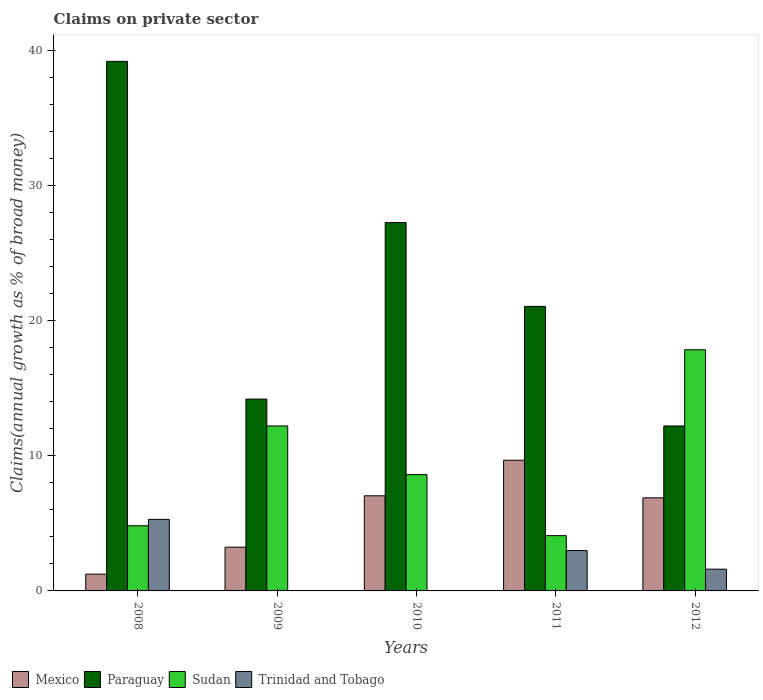How many groups of bars are there?
Your response must be concise. 5. Are the number of bars per tick equal to the number of legend labels?
Offer a very short reply. No. In how many cases, is the number of bars for a given year not equal to the number of legend labels?
Make the answer very short. 2. What is the percentage of broad money claimed on private sector in Sudan in 2010?
Offer a terse response. 8.61. Across all years, what is the maximum percentage of broad money claimed on private sector in Paraguay?
Your answer should be very brief. 39.21. Across all years, what is the minimum percentage of broad money claimed on private sector in Sudan?
Provide a short and direct response. 4.09. In which year was the percentage of broad money claimed on private sector in Sudan maximum?
Make the answer very short. 2012. What is the total percentage of broad money claimed on private sector in Paraguay in the graph?
Make the answer very short. 113.96. What is the difference between the percentage of broad money claimed on private sector in Sudan in 2011 and that in 2012?
Your answer should be compact. -13.76. What is the difference between the percentage of broad money claimed on private sector in Trinidad and Tobago in 2010 and the percentage of broad money claimed on private sector in Mexico in 2009?
Your answer should be compact. -3.24. What is the average percentage of broad money claimed on private sector in Sudan per year?
Provide a short and direct response. 9.52. In the year 2012, what is the difference between the percentage of broad money claimed on private sector in Mexico and percentage of broad money claimed on private sector in Paraguay?
Ensure brevity in your answer.  -5.32. What is the ratio of the percentage of broad money claimed on private sector in Sudan in 2009 to that in 2010?
Keep it short and to the point. 1.42. Is the percentage of broad money claimed on private sector in Paraguay in 2008 less than that in 2012?
Your response must be concise. No. What is the difference between the highest and the second highest percentage of broad money claimed on private sector in Trinidad and Tobago?
Make the answer very short. 2.31. What is the difference between the highest and the lowest percentage of broad money claimed on private sector in Trinidad and Tobago?
Provide a short and direct response. 5.3. Is it the case that in every year, the sum of the percentage of broad money claimed on private sector in Mexico and percentage of broad money claimed on private sector in Paraguay is greater than the sum of percentage of broad money claimed on private sector in Trinidad and Tobago and percentage of broad money claimed on private sector in Sudan?
Your response must be concise. No. Is it the case that in every year, the sum of the percentage of broad money claimed on private sector in Paraguay and percentage of broad money claimed on private sector in Trinidad and Tobago is greater than the percentage of broad money claimed on private sector in Sudan?
Make the answer very short. No. How many years are there in the graph?
Your answer should be very brief. 5. Are the values on the major ticks of Y-axis written in scientific E-notation?
Provide a succinct answer. No. Does the graph contain grids?
Give a very brief answer. No. Where does the legend appear in the graph?
Offer a very short reply. Bottom left. What is the title of the graph?
Keep it short and to the point. Claims on private sector. What is the label or title of the Y-axis?
Ensure brevity in your answer.  Claims(annual growth as % of broad money). What is the Claims(annual growth as % of broad money) of Mexico in 2008?
Your answer should be very brief. 1.24. What is the Claims(annual growth as % of broad money) of Paraguay in 2008?
Offer a very short reply. 39.21. What is the Claims(annual growth as % of broad money) of Sudan in 2008?
Ensure brevity in your answer.  4.82. What is the Claims(annual growth as % of broad money) in Trinidad and Tobago in 2008?
Ensure brevity in your answer.  5.3. What is the Claims(annual growth as % of broad money) in Mexico in 2009?
Offer a very short reply. 3.24. What is the Claims(annual growth as % of broad money) of Paraguay in 2009?
Keep it short and to the point. 14.2. What is the Claims(annual growth as % of broad money) of Sudan in 2009?
Make the answer very short. 12.21. What is the Claims(annual growth as % of broad money) in Trinidad and Tobago in 2009?
Keep it short and to the point. 0. What is the Claims(annual growth as % of broad money) of Mexico in 2010?
Provide a succinct answer. 7.04. What is the Claims(annual growth as % of broad money) in Paraguay in 2010?
Offer a very short reply. 27.27. What is the Claims(annual growth as % of broad money) of Sudan in 2010?
Make the answer very short. 8.61. What is the Claims(annual growth as % of broad money) in Trinidad and Tobago in 2010?
Offer a very short reply. 0. What is the Claims(annual growth as % of broad money) of Mexico in 2011?
Your answer should be very brief. 9.68. What is the Claims(annual growth as % of broad money) in Paraguay in 2011?
Offer a very short reply. 21.06. What is the Claims(annual growth as % of broad money) in Sudan in 2011?
Your answer should be very brief. 4.09. What is the Claims(annual growth as % of broad money) of Trinidad and Tobago in 2011?
Your answer should be very brief. 2.99. What is the Claims(annual growth as % of broad money) in Mexico in 2012?
Make the answer very short. 6.89. What is the Claims(annual growth as % of broad money) in Paraguay in 2012?
Your response must be concise. 12.21. What is the Claims(annual growth as % of broad money) of Sudan in 2012?
Offer a terse response. 17.85. What is the Claims(annual growth as % of broad money) in Trinidad and Tobago in 2012?
Provide a succinct answer. 1.61. Across all years, what is the maximum Claims(annual growth as % of broad money) in Mexico?
Give a very brief answer. 9.68. Across all years, what is the maximum Claims(annual growth as % of broad money) of Paraguay?
Your response must be concise. 39.21. Across all years, what is the maximum Claims(annual growth as % of broad money) of Sudan?
Give a very brief answer. 17.85. Across all years, what is the maximum Claims(annual growth as % of broad money) of Trinidad and Tobago?
Your answer should be very brief. 5.3. Across all years, what is the minimum Claims(annual growth as % of broad money) in Mexico?
Your answer should be very brief. 1.24. Across all years, what is the minimum Claims(annual growth as % of broad money) in Paraguay?
Offer a very short reply. 12.21. Across all years, what is the minimum Claims(annual growth as % of broad money) of Sudan?
Ensure brevity in your answer.  4.09. Across all years, what is the minimum Claims(annual growth as % of broad money) of Trinidad and Tobago?
Ensure brevity in your answer.  0. What is the total Claims(annual growth as % of broad money) in Mexico in the graph?
Your answer should be compact. 28.1. What is the total Claims(annual growth as % of broad money) in Paraguay in the graph?
Provide a succinct answer. 113.96. What is the total Claims(annual growth as % of broad money) of Sudan in the graph?
Keep it short and to the point. 47.59. What is the total Claims(annual growth as % of broad money) of Trinidad and Tobago in the graph?
Ensure brevity in your answer.  9.9. What is the difference between the Claims(annual growth as % of broad money) in Mexico in 2008 and that in 2009?
Give a very brief answer. -2. What is the difference between the Claims(annual growth as % of broad money) of Paraguay in 2008 and that in 2009?
Your answer should be compact. 25. What is the difference between the Claims(annual growth as % of broad money) in Sudan in 2008 and that in 2009?
Keep it short and to the point. -7.39. What is the difference between the Claims(annual growth as % of broad money) of Mexico in 2008 and that in 2010?
Make the answer very short. -5.8. What is the difference between the Claims(annual growth as % of broad money) of Paraguay in 2008 and that in 2010?
Offer a very short reply. 11.93. What is the difference between the Claims(annual growth as % of broad money) in Sudan in 2008 and that in 2010?
Your answer should be compact. -3.79. What is the difference between the Claims(annual growth as % of broad money) in Mexico in 2008 and that in 2011?
Provide a succinct answer. -8.43. What is the difference between the Claims(annual growth as % of broad money) in Paraguay in 2008 and that in 2011?
Keep it short and to the point. 18.14. What is the difference between the Claims(annual growth as % of broad money) in Sudan in 2008 and that in 2011?
Keep it short and to the point. 0.73. What is the difference between the Claims(annual growth as % of broad money) in Trinidad and Tobago in 2008 and that in 2011?
Your response must be concise. 2.31. What is the difference between the Claims(annual growth as % of broad money) of Mexico in 2008 and that in 2012?
Ensure brevity in your answer.  -5.65. What is the difference between the Claims(annual growth as % of broad money) of Paraguay in 2008 and that in 2012?
Provide a succinct answer. 27. What is the difference between the Claims(annual growth as % of broad money) of Sudan in 2008 and that in 2012?
Your answer should be very brief. -13.03. What is the difference between the Claims(annual growth as % of broad money) of Trinidad and Tobago in 2008 and that in 2012?
Your answer should be very brief. 3.68. What is the difference between the Claims(annual growth as % of broad money) of Mexico in 2009 and that in 2010?
Keep it short and to the point. -3.8. What is the difference between the Claims(annual growth as % of broad money) of Paraguay in 2009 and that in 2010?
Ensure brevity in your answer.  -13.07. What is the difference between the Claims(annual growth as % of broad money) of Sudan in 2009 and that in 2010?
Make the answer very short. 3.6. What is the difference between the Claims(annual growth as % of broad money) in Mexico in 2009 and that in 2011?
Keep it short and to the point. -6.44. What is the difference between the Claims(annual growth as % of broad money) of Paraguay in 2009 and that in 2011?
Make the answer very short. -6.86. What is the difference between the Claims(annual growth as % of broad money) of Sudan in 2009 and that in 2011?
Give a very brief answer. 8.12. What is the difference between the Claims(annual growth as % of broad money) of Mexico in 2009 and that in 2012?
Make the answer very short. -3.65. What is the difference between the Claims(annual growth as % of broad money) of Paraguay in 2009 and that in 2012?
Offer a terse response. 1.99. What is the difference between the Claims(annual growth as % of broad money) of Sudan in 2009 and that in 2012?
Offer a terse response. -5.64. What is the difference between the Claims(annual growth as % of broad money) in Mexico in 2010 and that in 2011?
Provide a short and direct response. -2.63. What is the difference between the Claims(annual growth as % of broad money) of Paraguay in 2010 and that in 2011?
Make the answer very short. 6.21. What is the difference between the Claims(annual growth as % of broad money) of Sudan in 2010 and that in 2011?
Ensure brevity in your answer.  4.52. What is the difference between the Claims(annual growth as % of broad money) in Mexico in 2010 and that in 2012?
Provide a short and direct response. 0.15. What is the difference between the Claims(annual growth as % of broad money) of Paraguay in 2010 and that in 2012?
Provide a short and direct response. 15.06. What is the difference between the Claims(annual growth as % of broad money) in Sudan in 2010 and that in 2012?
Provide a succinct answer. -9.24. What is the difference between the Claims(annual growth as % of broad money) of Mexico in 2011 and that in 2012?
Make the answer very short. 2.78. What is the difference between the Claims(annual growth as % of broad money) of Paraguay in 2011 and that in 2012?
Offer a very short reply. 8.85. What is the difference between the Claims(annual growth as % of broad money) of Sudan in 2011 and that in 2012?
Offer a terse response. -13.76. What is the difference between the Claims(annual growth as % of broad money) in Trinidad and Tobago in 2011 and that in 2012?
Your response must be concise. 1.38. What is the difference between the Claims(annual growth as % of broad money) of Mexico in 2008 and the Claims(annual growth as % of broad money) of Paraguay in 2009?
Make the answer very short. -12.96. What is the difference between the Claims(annual growth as % of broad money) in Mexico in 2008 and the Claims(annual growth as % of broad money) in Sudan in 2009?
Provide a succinct answer. -10.97. What is the difference between the Claims(annual growth as % of broad money) in Paraguay in 2008 and the Claims(annual growth as % of broad money) in Sudan in 2009?
Keep it short and to the point. 27. What is the difference between the Claims(annual growth as % of broad money) of Mexico in 2008 and the Claims(annual growth as % of broad money) of Paraguay in 2010?
Offer a very short reply. -26.03. What is the difference between the Claims(annual growth as % of broad money) in Mexico in 2008 and the Claims(annual growth as % of broad money) in Sudan in 2010?
Give a very brief answer. -7.37. What is the difference between the Claims(annual growth as % of broad money) of Paraguay in 2008 and the Claims(annual growth as % of broad money) of Sudan in 2010?
Your answer should be very brief. 30.6. What is the difference between the Claims(annual growth as % of broad money) in Mexico in 2008 and the Claims(annual growth as % of broad money) in Paraguay in 2011?
Offer a terse response. -19.82. What is the difference between the Claims(annual growth as % of broad money) of Mexico in 2008 and the Claims(annual growth as % of broad money) of Sudan in 2011?
Ensure brevity in your answer.  -2.85. What is the difference between the Claims(annual growth as % of broad money) in Mexico in 2008 and the Claims(annual growth as % of broad money) in Trinidad and Tobago in 2011?
Offer a very short reply. -1.75. What is the difference between the Claims(annual growth as % of broad money) of Paraguay in 2008 and the Claims(annual growth as % of broad money) of Sudan in 2011?
Your answer should be compact. 35.12. What is the difference between the Claims(annual growth as % of broad money) of Paraguay in 2008 and the Claims(annual growth as % of broad money) of Trinidad and Tobago in 2011?
Give a very brief answer. 36.22. What is the difference between the Claims(annual growth as % of broad money) in Sudan in 2008 and the Claims(annual growth as % of broad money) in Trinidad and Tobago in 2011?
Give a very brief answer. 1.83. What is the difference between the Claims(annual growth as % of broad money) in Mexico in 2008 and the Claims(annual growth as % of broad money) in Paraguay in 2012?
Offer a very short reply. -10.97. What is the difference between the Claims(annual growth as % of broad money) of Mexico in 2008 and the Claims(annual growth as % of broad money) of Sudan in 2012?
Keep it short and to the point. -16.61. What is the difference between the Claims(annual growth as % of broad money) in Mexico in 2008 and the Claims(annual growth as % of broad money) in Trinidad and Tobago in 2012?
Ensure brevity in your answer.  -0.37. What is the difference between the Claims(annual growth as % of broad money) in Paraguay in 2008 and the Claims(annual growth as % of broad money) in Sudan in 2012?
Provide a short and direct response. 21.35. What is the difference between the Claims(annual growth as % of broad money) of Paraguay in 2008 and the Claims(annual growth as % of broad money) of Trinidad and Tobago in 2012?
Provide a succinct answer. 37.6. What is the difference between the Claims(annual growth as % of broad money) in Sudan in 2008 and the Claims(annual growth as % of broad money) in Trinidad and Tobago in 2012?
Ensure brevity in your answer.  3.21. What is the difference between the Claims(annual growth as % of broad money) in Mexico in 2009 and the Claims(annual growth as % of broad money) in Paraguay in 2010?
Your answer should be very brief. -24.03. What is the difference between the Claims(annual growth as % of broad money) in Mexico in 2009 and the Claims(annual growth as % of broad money) in Sudan in 2010?
Provide a short and direct response. -5.37. What is the difference between the Claims(annual growth as % of broad money) of Paraguay in 2009 and the Claims(annual growth as % of broad money) of Sudan in 2010?
Your response must be concise. 5.6. What is the difference between the Claims(annual growth as % of broad money) in Mexico in 2009 and the Claims(annual growth as % of broad money) in Paraguay in 2011?
Your answer should be compact. -17.82. What is the difference between the Claims(annual growth as % of broad money) of Mexico in 2009 and the Claims(annual growth as % of broad money) of Sudan in 2011?
Make the answer very short. -0.85. What is the difference between the Claims(annual growth as % of broad money) in Mexico in 2009 and the Claims(annual growth as % of broad money) in Trinidad and Tobago in 2011?
Your answer should be very brief. 0.25. What is the difference between the Claims(annual growth as % of broad money) in Paraguay in 2009 and the Claims(annual growth as % of broad money) in Sudan in 2011?
Provide a succinct answer. 10.11. What is the difference between the Claims(annual growth as % of broad money) of Paraguay in 2009 and the Claims(annual growth as % of broad money) of Trinidad and Tobago in 2011?
Make the answer very short. 11.22. What is the difference between the Claims(annual growth as % of broad money) of Sudan in 2009 and the Claims(annual growth as % of broad money) of Trinidad and Tobago in 2011?
Keep it short and to the point. 9.22. What is the difference between the Claims(annual growth as % of broad money) in Mexico in 2009 and the Claims(annual growth as % of broad money) in Paraguay in 2012?
Your answer should be very brief. -8.97. What is the difference between the Claims(annual growth as % of broad money) of Mexico in 2009 and the Claims(annual growth as % of broad money) of Sudan in 2012?
Provide a succinct answer. -14.62. What is the difference between the Claims(annual growth as % of broad money) in Mexico in 2009 and the Claims(annual growth as % of broad money) in Trinidad and Tobago in 2012?
Offer a very short reply. 1.63. What is the difference between the Claims(annual growth as % of broad money) in Paraguay in 2009 and the Claims(annual growth as % of broad money) in Sudan in 2012?
Your answer should be compact. -3.65. What is the difference between the Claims(annual growth as % of broad money) of Paraguay in 2009 and the Claims(annual growth as % of broad money) of Trinidad and Tobago in 2012?
Give a very brief answer. 12.59. What is the difference between the Claims(annual growth as % of broad money) in Sudan in 2009 and the Claims(annual growth as % of broad money) in Trinidad and Tobago in 2012?
Your answer should be very brief. 10.6. What is the difference between the Claims(annual growth as % of broad money) in Mexico in 2010 and the Claims(annual growth as % of broad money) in Paraguay in 2011?
Offer a very short reply. -14.02. What is the difference between the Claims(annual growth as % of broad money) in Mexico in 2010 and the Claims(annual growth as % of broad money) in Sudan in 2011?
Ensure brevity in your answer.  2.95. What is the difference between the Claims(annual growth as % of broad money) of Mexico in 2010 and the Claims(annual growth as % of broad money) of Trinidad and Tobago in 2011?
Provide a succinct answer. 4.06. What is the difference between the Claims(annual growth as % of broad money) in Paraguay in 2010 and the Claims(annual growth as % of broad money) in Sudan in 2011?
Offer a very short reply. 23.18. What is the difference between the Claims(annual growth as % of broad money) in Paraguay in 2010 and the Claims(annual growth as % of broad money) in Trinidad and Tobago in 2011?
Your answer should be very brief. 24.29. What is the difference between the Claims(annual growth as % of broad money) in Sudan in 2010 and the Claims(annual growth as % of broad money) in Trinidad and Tobago in 2011?
Offer a terse response. 5.62. What is the difference between the Claims(annual growth as % of broad money) of Mexico in 2010 and the Claims(annual growth as % of broad money) of Paraguay in 2012?
Your response must be concise. -5.17. What is the difference between the Claims(annual growth as % of broad money) of Mexico in 2010 and the Claims(annual growth as % of broad money) of Sudan in 2012?
Keep it short and to the point. -10.81. What is the difference between the Claims(annual growth as % of broad money) in Mexico in 2010 and the Claims(annual growth as % of broad money) in Trinidad and Tobago in 2012?
Provide a short and direct response. 5.43. What is the difference between the Claims(annual growth as % of broad money) in Paraguay in 2010 and the Claims(annual growth as % of broad money) in Sudan in 2012?
Provide a succinct answer. 9.42. What is the difference between the Claims(annual growth as % of broad money) of Paraguay in 2010 and the Claims(annual growth as % of broad money) of Trinidad and Tobago in 2012?
Your answer should be compact. 25.66. What is the difference between the Claims(annual growth as % of broad money) of Sudan in 2010 and the Claims(annual growth as % of broad money) of Trinidad and Tobago in 2012?
Offer a very short reply. 7. What is the difference between the Claims(annual growth as % of broad money) of Mexico in 2011 and the Claims(annual growth as % of broad money) of Paraguay in 2012?
Your answer should be very brief. -2.54. What is the difference between the Claims(annual growth as % of broad money) in Mexico in 2011 and the Claims(annual growth as % of broad money) in Sudan in 2012?
Offer a very short reply. -8.18. What is the difference between the Claims(annual growth as % of broad money) of Mexico in 2011 and the Claims(annual growth as % of broad money) of Trinidad and Tobago in 2012?
Provide a succinct answer. 8.07. What is the difference between the Claims(annual growth as % of broad money) of Paraguay in 2011 and the Claims(annual growth as % of broad money) of Sudan in 2012?
Give a very brief answer. 3.21. What is the difference between the Claims(annual growth as % of broad money) of Paraguay in 2011 and the Claims(annual growth as % of broad money) of Trinidad and Tobago in 2012?
Give a very brief answer. 19.45. What is the difference between the Claims(annual growth as % of broad money) in Sudan in 2011 and the Claims(annual growth as % of broad money) in Trinidad and Tobago in 2012?
Provide a short and direct response. 2.48. What is the average Claims(annual growth as % of broad money) of Mexico per year?
Your answer should be compact. 5.62. What is the average Claims(annual growth as % of broad money) of Paraguay per year?
Provide a short and direct response. 22.79. What is the average Claims(annual growth as % of broad money) of Sudan per year?
Your answer should be very brief. 9.52. What is the average Claims(annual growth as % of broad money) in Trinidad and Tobago per year?
Keep it short and to the point. 1.98. In the year 2008, what is the difference between the Claims(annual growth as % of broad money) of Mexico and Claims(annual growth as % of broad money) of Paraguay?
Give a very brief answer. -37.97. In the year 2008, what is the difference between the Claims(annual growth as % of broad money) of Mexico and Claims(annual growth as % of broad money) of Sudan?
Make the answer very short. -3.58. In the year 2008, what is the difference between the Claims(annual growth as % of broad money) of Mexico and Claims(annual growth as % of broad money) of Trinidad and Tobago?
Keep it short and to the point. -4.05. In the year 2008, what is the difference between the Claims(annual growth as % of broad money) in Paraguay and Claims(annual growth as % of broad money) in Sudan?
Provide a succinct answer. 34.39. In the year 2008, what is the difference between the Claims(annual growth as % of broad money) in Paraguay and Claims(annual growth as % of broad money) in Trinidad and Tobago?
Offer a terse response. 33.91. In the year 2008, what is the difference between the Claims(annual growth as % of broad money) in Sudan and Claims(annual growth as % of broad money) in Trinidad and Tobago?
Ensure brevity in your answer.  -0.47. In the year 2009, what is the difference between the Claims(annual growth as % of broad money) in Mexico and Claims(annual growth as % of broad money) in Paraguay?
Give a very brief answer. -10.97. In the year 2009, what is the difference between the Claims(annual growth as % of broad money) of Mexico and Claims(annual growth as % of broad money) of Sudan?
Ensure brevity in your answer.  -8.97. In the year 2009, what is the difference between the Claims(annual growth as % of broad money) in Paraguay and Claims(annual growth as % of broad money) in Sudan?
Give a very brief answer. 1.99. In the year 2010, what is the difference between the Claims(annual growth as % of broad money) in Mexico and Claims(annual growth as % of broad money) in Paraguay?
Offer a very short reply. -20.23. In the year 2010, what is the difference between the Claims(annual growth as % of broad money) of Mexico and Claims(annual growth as % of broad money) of Sudan?
Provide a short and direct response. -1.57. In the year 2010, what is the difference between the Claims(annual growth as % of broad money) of Paraguay and Claims(annual growth as % of broad money) of Sudan?
Keep it short and to the point. 18.66. In the year 2011, what is the difference between the Claims(annual growth as % of broad money) in Mexico and Claims(annual growth as % of broad money) in Paraguay?
Provide a short and direct response. -11.39. In the year 2011, what is the difference between the Claims(annual growth as % of broad money) in Mexico and Claims(annual growth as % of broad money) in Sudan?
Provide a short and direct response. 5.58. In the year 2011, what is the difference between the Claims(annual growth as % of broad money) of Mexico and Claims(annual growth as % of broad money) of Trinidad and Tobago?
Give a very brief answer. 6.69. In the year 2011, what is the difference between the Claims(annual growth as % of broad money) in Paraguay and Claims(annual growth as % of broad money) in Sudan?
Your answer should be compact. 16.97. In the year 2011, what is the difference between the Claims(annual growth as % of broad money) of Paraguay and Claims(annual growth as % of broad money) of Trinidad and Tobago?
Your answer should be very brief. 18.08. In the year 2011, what is the difference between the Claims(annual growth as % of broad money) in Sudan and Claims(annual growth as % of broad money) in Trinidad and Tobago?
Your answer should be very brief. 1.1. In the year 2012, what is the difference between the Claims(annual growth as % of broad money) of Mexico and Claims(annual growth as % of broad money) of Paraguay?
Offer a very short reply. -5.32. In the year 2012, what is the difference between the Claims(annual growth as % of broad money) in Mexico and Claims(annual growth as % of broad money) in Sudan?
Keep it short and to the point. -10.96. In the year 2012, what is the difference between the Claims(annual growth as % of broad money) in Mexico and Claims(annual growth as % of broad money) in Trinidad and Tobago?
Provide a short and direct response. 5.28. In the year 2012, what is the difference between the Claims(annual growth as % of broad money) of Paraguay and Claims(annual growth as % of broad money) of Sudan?
Your answer should be compact. -5.64. In the year 2012, what is the difference between the Claims(annual growth as % of broad money) of Paraguay and Claims(annual growth as % of broad money) of Trinidad and Tobago?
Ensure brevity in your answer.  10.6. In the year 2012, what is the difference between the Claims(annual growth as % of broad money) of Sudan and Claims(annual growth as % of broad money) of Trinidad and Tobago?
Ensure brevity in your answer.  16.24. What is the ratio of the Claims(annual growth as % of broad money) of Mexico in 2008 to that in 2009?
Make the answer very short. 0.38. What is the ratio of the Claims(annual growth as % of broad money) of Paraguay in 2008 to that in 2009?
Your response must be concise. 2.76. What is the ratio of the Claims(annual growth as % of broad money) of Sudan in 2008 to that in 2009?
Give a very brief answer. 0.39. What is the ratio of the Claims(annual growth as % of broad money) in Mexico in 2008 to that in 2010?
Provide a short and direct response. 0.18. What is the ratio of the Claims(annual growth as % of broad money) in Paraguay in 2008 to that in 2010?
Ensure brevity in your answer.  1.44. What is the ratio of the Claims(annual growth as % of broad money) of Sudan in 2008 to that in 2010?
Your answer should be very brief. 0.56. What is the ratio of the Claims(annual growth as % of broad money) of Mexico in 2008 to that in 2011?
Keep it short and to the point. 0.13. What is the ratio of the Claims(annual growth as % of broad money) of Paraguay in 2008 to that in 2011?
Make the answer very short. 1.86. What is the ratio of the Claims(annual growth as % of broad money) of Sudan in 2008 to that in 2011?
Provide a succinct answer. 1.18. What is the ratio of the Claims(annual growth as % of broad money) in Trinidad and Tobago in 2008 to that in 2011?
Offer a very short reply. 1.77. What is the ratio of the Claims(annual growth as % of broad money) of Mexico in 2008 to that in 2012?
Ensure brevity in your answer.  0.18. What is the ratio of the Claims(annual growth as % of broad money) of Paraguay in 2008 to that in 2012?
Offer a terse response. 3.21. What is the ratio of the Claims(annual growth as % of broad money) of Sudan in 2008 to that in 2012?
Keep it short and to the point. 0.27. What is the ratio of the Claims(annual growth as % of broad money) in Trinidad and Tobago in 2008 to that in 2012?
Provide a succinct answer. 3.29. What is the ratio of the Claims(annual growth as % of broad money) in Mexico in 2009 to that in 2010?
Make the answer very short. 0.46. What is the ratio of the Claims(annual growth as % of broad money) in Paraguay in 2009 to that in 2010?
Give a very brief answer. 0.52. What is the ratio of the Claims(annual growth as % of broad money) of Sudan in 2009 to that in 2010?
Your response must be concise. 1.42. What is the ratio of the Claims(annual growth as % of broad money) in Mexico in 2009 to that in 2011?
Provide a succinct answer. 0.33. What is the ratio of the Claims(annual growth as % of broad money) in Paraguay in 2009 to that in 2011?
Your answer should be compact. 0.67. What is the ratio of the Claims(annual growth as % of broad money) in Sudan in 2009 to that in 2011?
Give a very brief answer. 2.98. What is the ratio of the Claims(annual growth as % of broad money) in Mexico in 2009 to that in 2012?
Offer a terse response. 0.47. What is the ratio of the Claims(annual growth as % of broad money) in Paraguay in 2009 to that in 2012?
Your answer should be very brief. 1.16. What is the ratio of the Claims(annual growth as % of broad money) in Sudan in 2009 to that in 2012?
Your answer should be very brief. 0.68. What is the ratio of the Claims(annual growth as % of broad money) in Mexico in 2010 to that in 2011?
Offer a terse response. 0.73. What is the ratio of the Claims(annual growth as % of broad money) of Paraguay in 2010 to that in 2011?
Offer a very short reply. 1.29. What is the ratio of the Claims(annual growth as % of broad money) in Sudan in 2010 to that in 2011?
Your response must be concise. 2.1. What is the ratio of the Claims(annual growth as % of broad money) in Mexico in 2010 to that in 2012?
Your response must be concise. 1.02. What is the ratio of the Claims(annual growth as % of broad money) of Paraguay in 2010 to that in 2012?
Your response must be concise. 2.23. What is the ratio of the Claims(annual growth as % of broad money) of Sudan in 2010 to that in 2012?
Offer a terse response. 0.48. What is the ratio of the Claims(annual growth as % of broad money) in Mexico in 2011 to that in 2012?
Your answer should be compact. 1.4. What is the ratio of the Claims(annual growth as % of broad money) in Paraguay in 2011 to that in 2012?
Offer a very short reply. 1.72. What is the ratio of the Claims(annual growth as % of broad money) of Sudan in 2011 to that in 2012?
Your response must be concise. 0.23. What is the ratio of the Claims(annual growth as % of broad money) of Trinidad and Tobago in 2011 to that in 2012?
Your answer should be compact. 1.85. What is the difference between the highest and the second highest Claims(annual growth as % of broad money) of Mexico?
Keep it short and to the point. 2.63. What is the difference between the highest and the second highest Claims(annual growth as % of broad money) of Paraguay?
Provide a succinct answer. 11.93. What is the difference between the highest and the second highest Claims(annual growth as % of broad money) of Sudan?
Give a very brief answer. 5.64. What is the difference between the highest and the second highest Claims(annual growth as % of broad money) of Trinidad and Tobago?
Your response must be concise. 2.31. What is the difference between the highest and the lowest Claims(annual growth as % of broad money) of Mexico?
Keep it short and to the point. 8.43. What is the difference between the highest and the lowest Claims(annual growth as % of broad money) of Paraguay?
Keep it short and to the point. 27. What is the difference between the highest and the lowest Claims(annual growth as % of broad money) of Sudan?
Keep it short and to the point. 13.76. What is the difference between the highest and the lowest Claims(annual growth as % of broad money) of Trinidad and Tobago?
Provide a short and direct response. 5.3. 